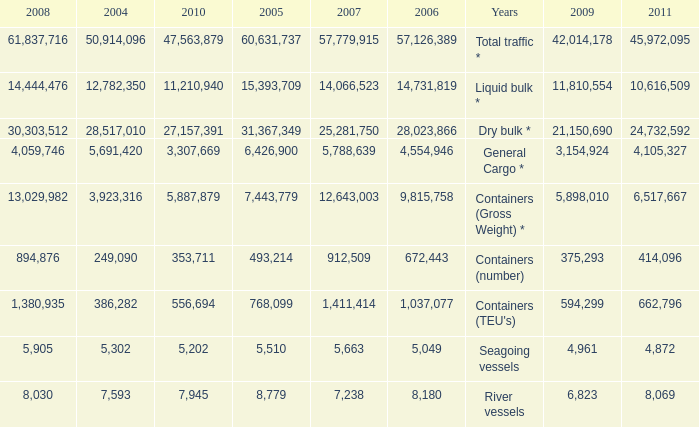What is the highest value in 2011 with less than 5,049 in 2006 and less than 1,380,935 in 2008? None. 